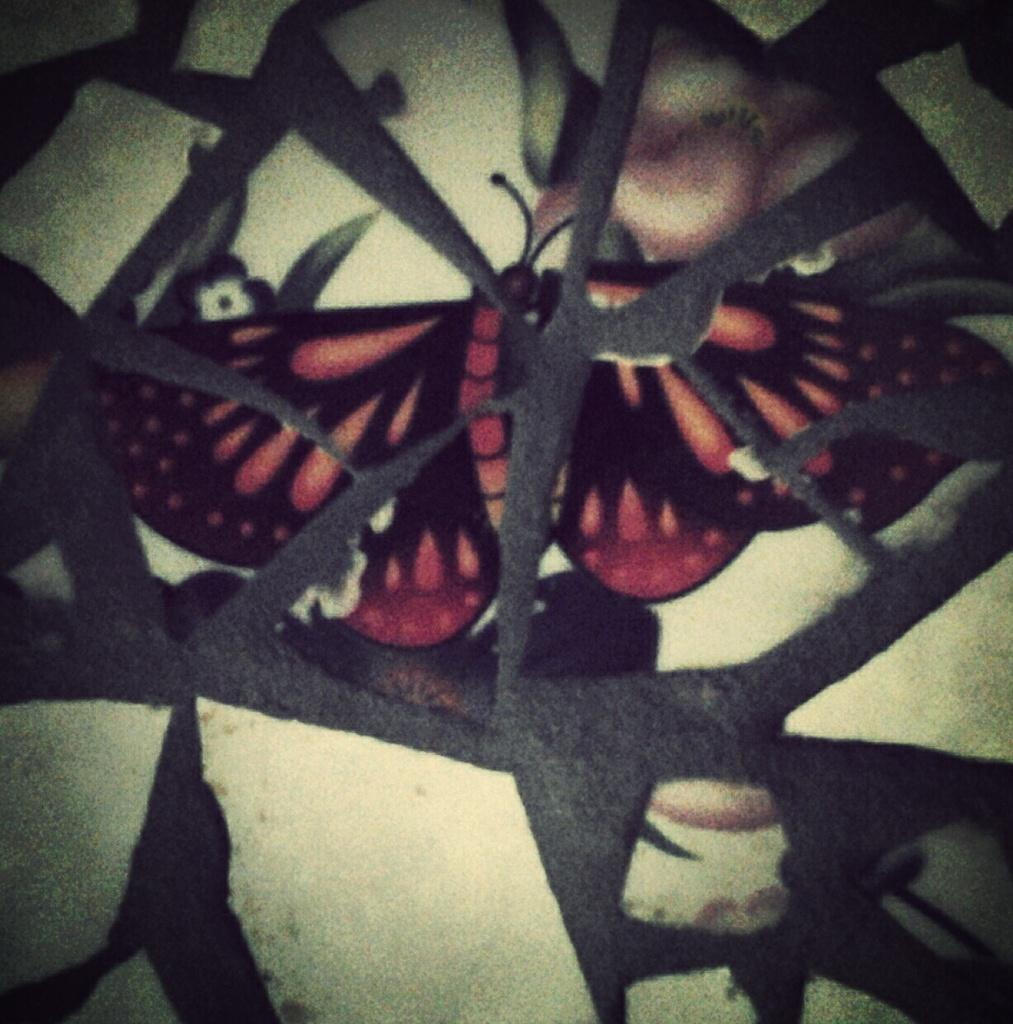What is present on the wall in the image? The wall has a design of a butterfly and flowers. Can you describe the design on the wall? The design on the wall features a butterfly and flowers. What type of doctor can be seen examining the wall in the image? There is no doctor present in the image, and the wall is not being examined. 